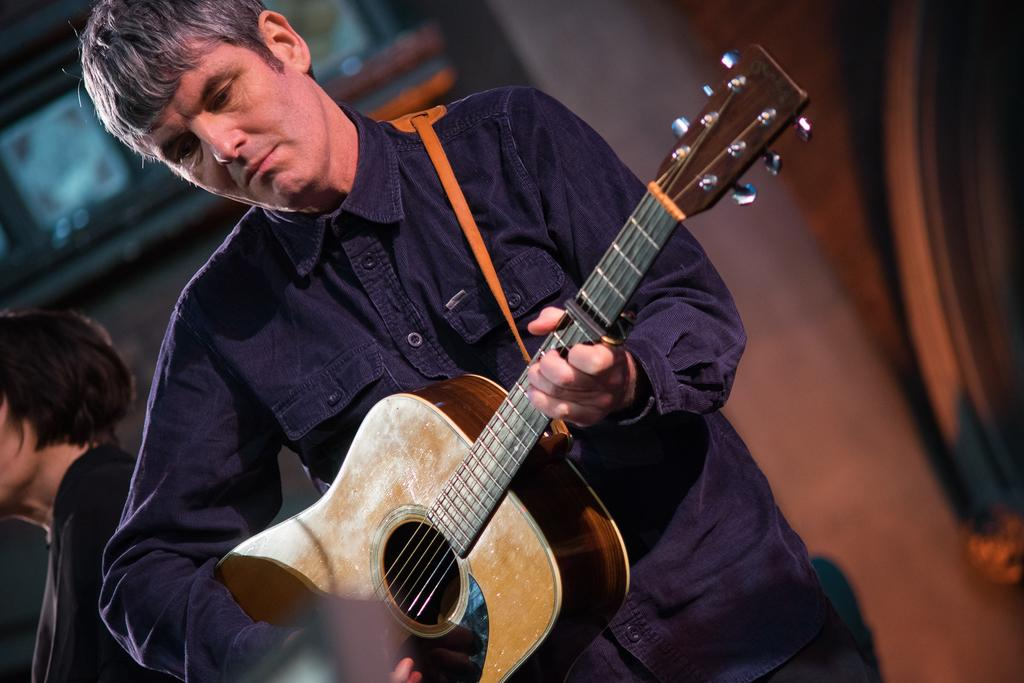What is the man in the image holding? The man is holding a guitar in the image. Can you describe the other person in the image? There is another person in a black dress in the image. What can be observed about the background of the people in the image? The background of the people is blurred. What type of structure can be seen in the background of the image? There is no structure visible in the background of the image. Can you tell me how many yaks are present in the image? There are no yaks present in the image. 